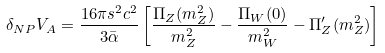<formula> <loc_0><loc_0><loc_500><loc_500>\delta _ { N P } V _ { A } = \frac { 1 6 \pi s ^ { 2 } c ^ { 2 } } { 3 \bar { \alpha } } \left [ \frac { \Pi _ { Z } ( m _ { Z } ^ { 2 } ) } { m _ { Z } ^ { 2 } } - \frac { \Pi _ { W } ( 0 ) } { m _ { W } ^ { 2 } } - \Pi _ { Z } ^ { \prime } ( m _ { Z } ^ { 2 } ) \right ]</formula> 